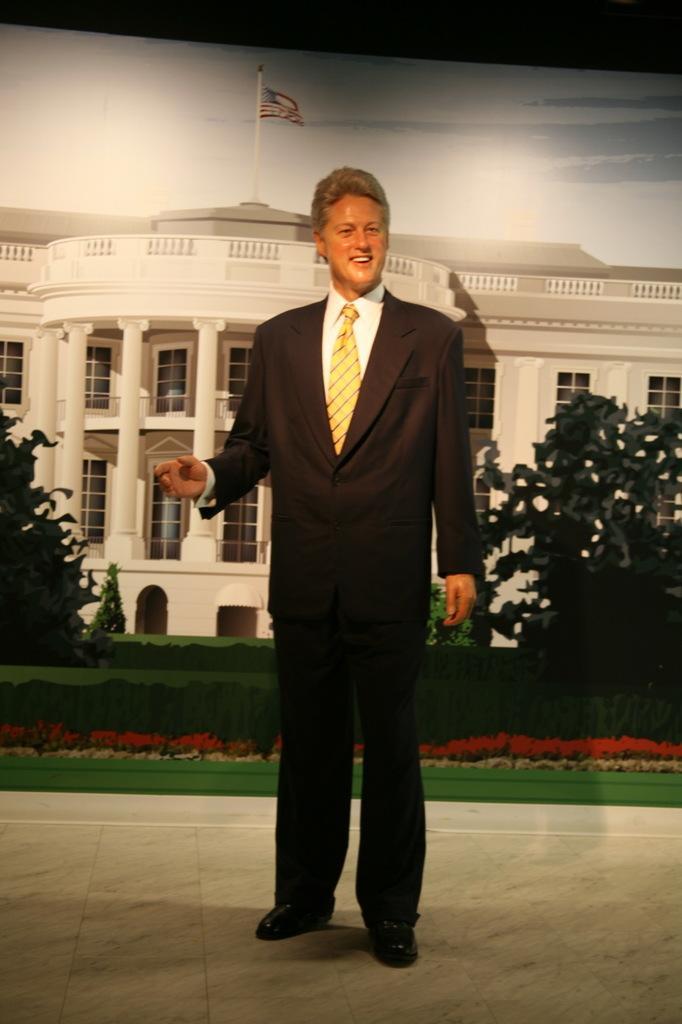Please provide a concise description of this image. In this picture I can see statue of a man standing and smiling, and in the background it is looking like a poster with a building, trees, plants, flag and sky. 